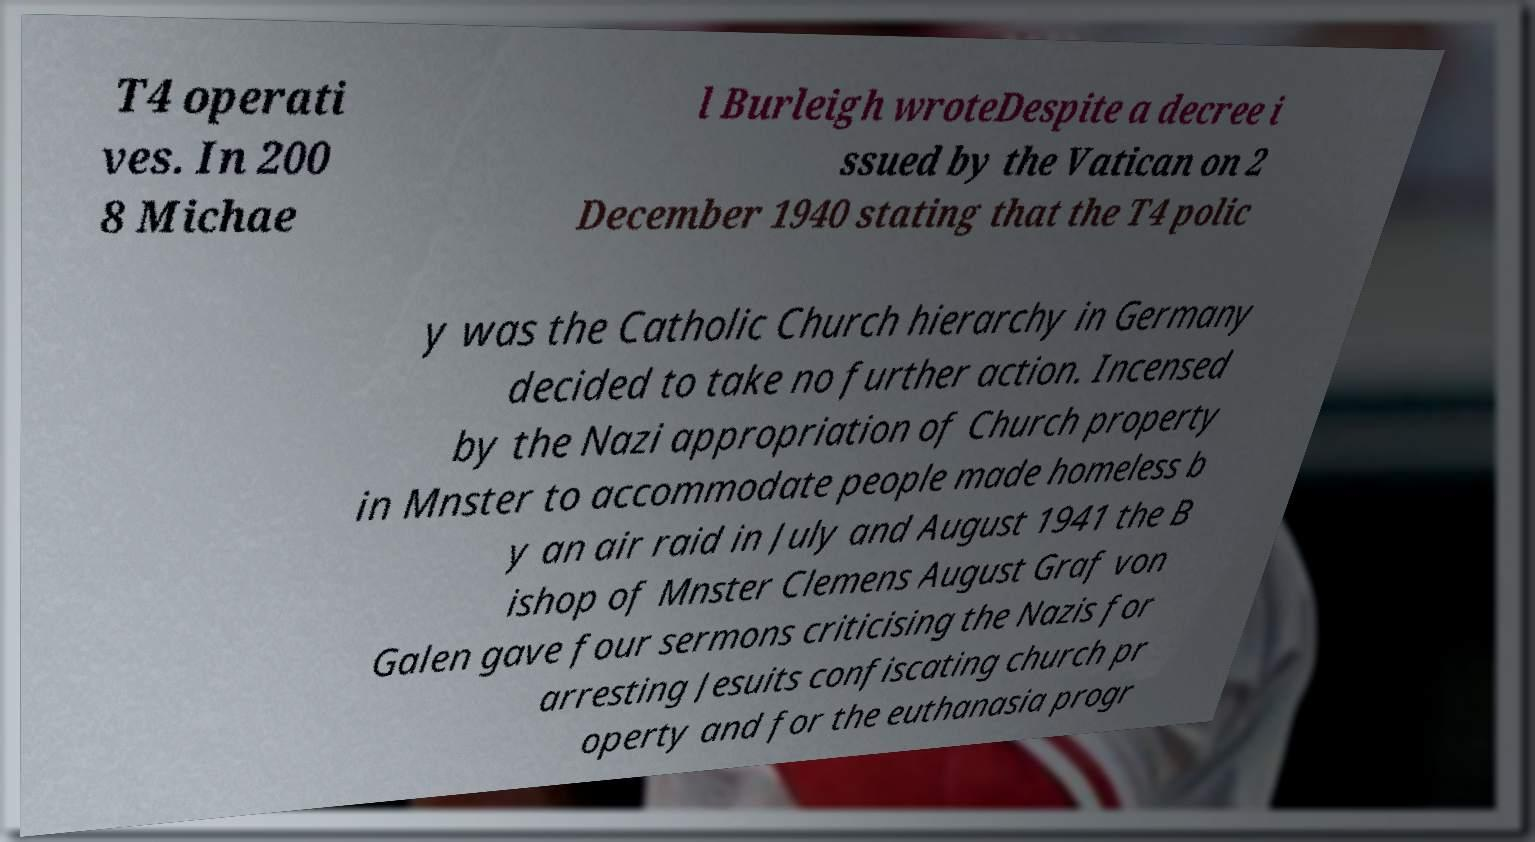Could you assist in decoding the text presented in this image and type it out clearly? T4 operati ves. In 200 8 Michae l Burleigh wroteDespite a decree i ssued by the Vatican on 2 December 1940 stating that the T4 polic y was the Catholic Church hierarchy in Germany decided to take no further action. Incensed by the Nazi appropriation of Church property in Mnster to accommodate people made homeless b y an air raid in July and August 1941 the B ishop of Mnster Clemens August Graf von Galen gave four sermons criticising the Nazis for arresting Jesuits confiscating church pr operty and for the euthanasia progr 